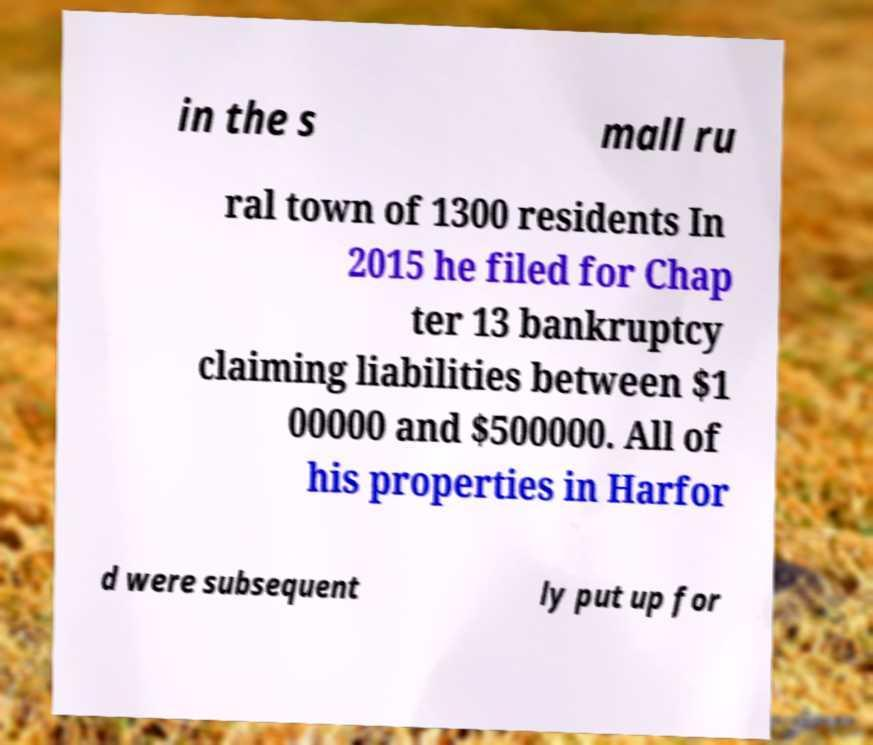Can you accurately transcribe the text from the provided image for me? in the s mall ru ral town of 1300 residents In 2015 he filed for Chap ter 13 bankruptcy claiming liabilities between $1 00000 and $500000. All of his properties in Harfor d were subsequent ly put up for 